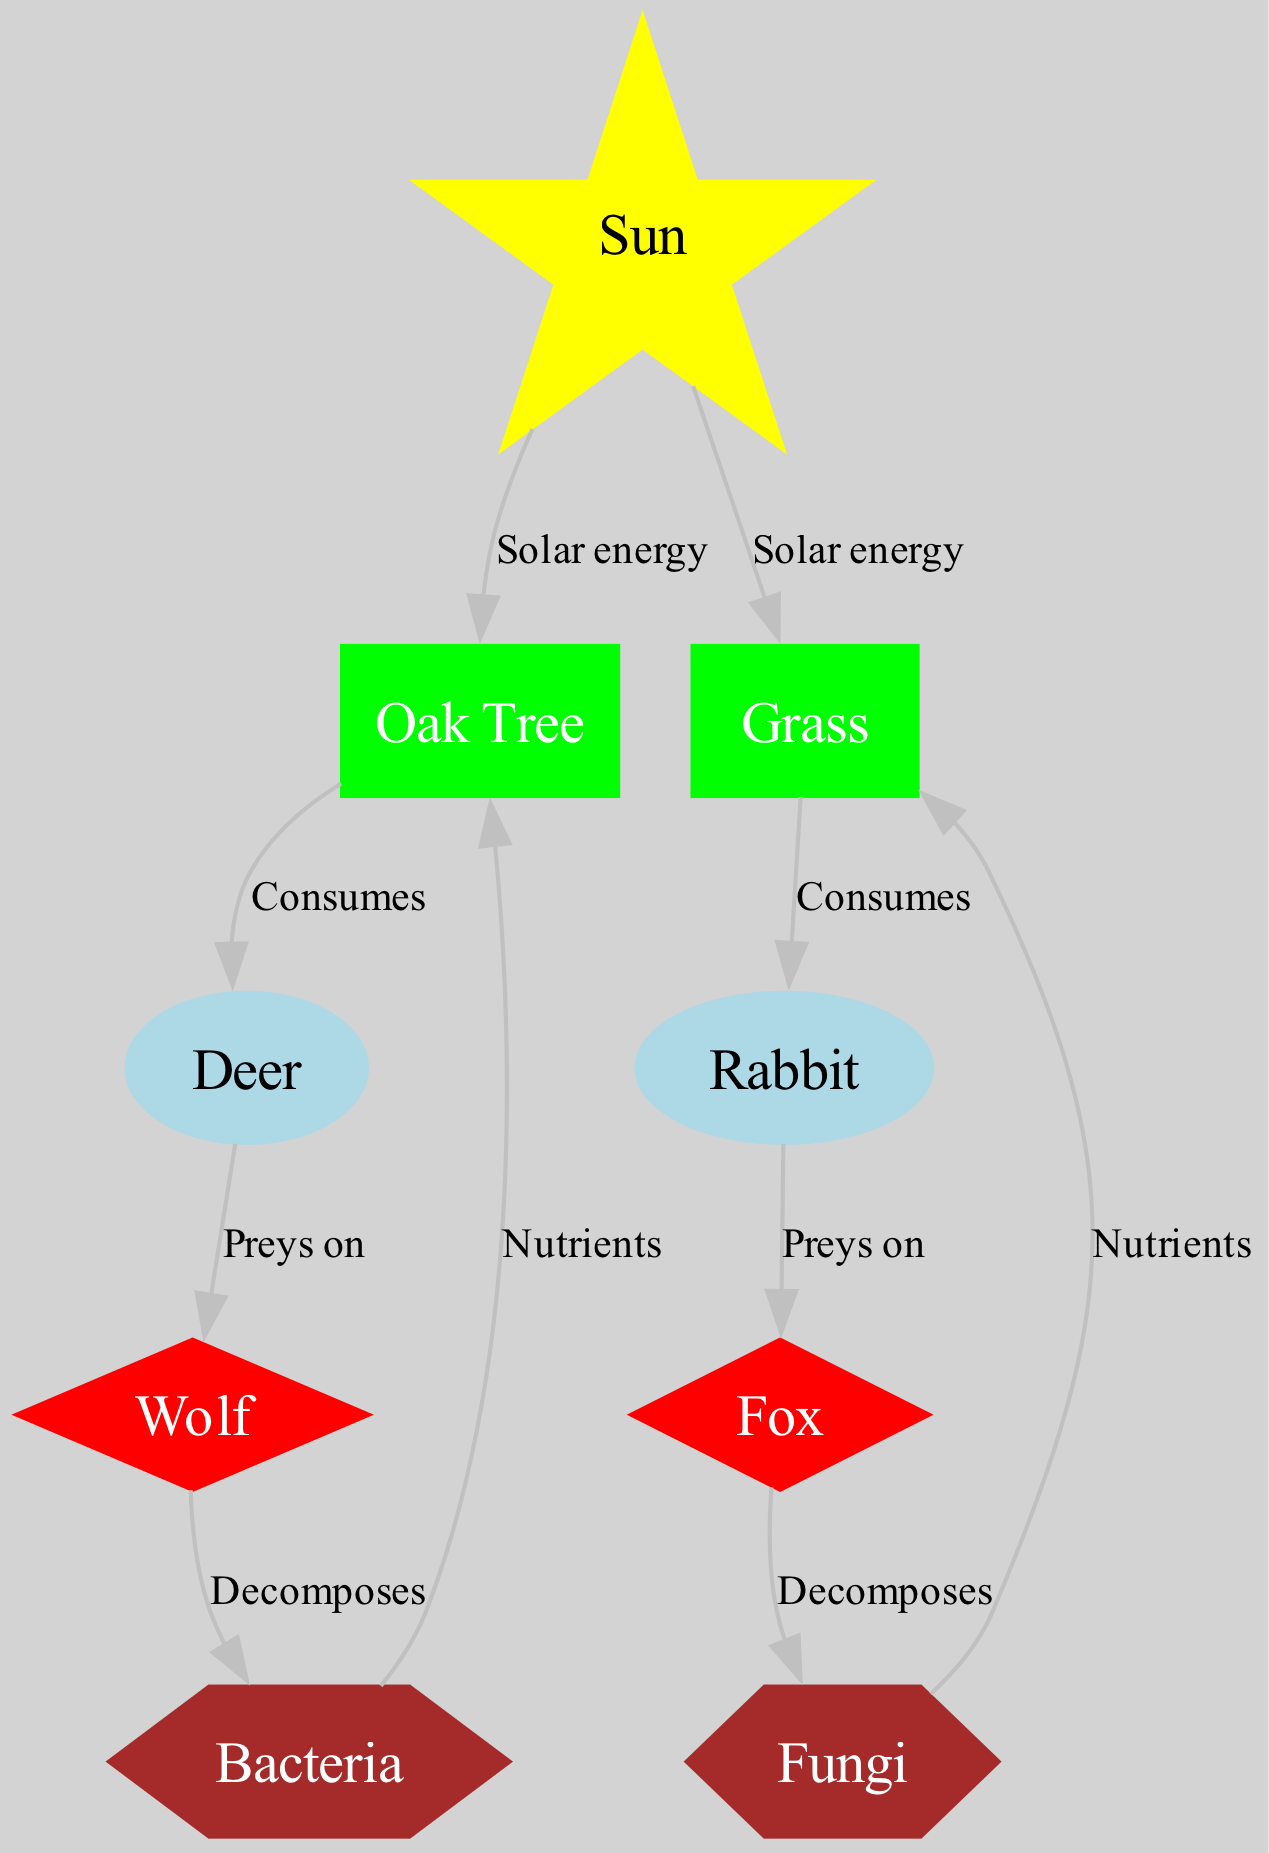What is the energy source in this food web? The food web diagram identifies the Sun as the primary energy source, indicated by its unique star shape and yellow color.
Answer: Sun How many primary consumers are in the diagram? By examining the nodes in the diagram, we see that there are two primary consumers listed: Deer and Rabbit.
Answer: 2 What type of node is the Oak Tree? The Oak Tree node is classified as a producer, represented by a rectangle and filled with green color.
Answer: producer Which organism preys on the Deer? The edges in the diagram indicate that the Wolf preys on the Deer, as shown by a direct connection leading to the Wolf node.
Answer: Wolf What relationship is represented by the edge from Rabbit to Fox? The edge from Rabbit to Fox represents the relationship "Preys on," indicating the Fox is a predator of the Rabbit.
Answer: Preys on How do Bacteria contribute to the Oak Tree? The diagram shows that Bacteria provide nutrients to the Oak Tree, as indicated by the directed edge labeled "Nutrients."
Answer: Nutrients Which decomposer is linked to the Wolf? Looking at the edge connections, the decomposer linked to the Wolf is Bacteria, showing the cycle of decomposition.
Answer: Bacteria What type of consumer is associated with the Rabbit? The Rabbit is categorized as a primary consumer, represented by the ellipse shape and light blue color in the diagram.
Answer: primary consumer What is the role of Fungi in this ecosystem? The Fungi act as decomposers, helping to recycle nutrients back into the ecosystem, as indicated by its connections providing nutrients to Grass.
Answer: decomposer 